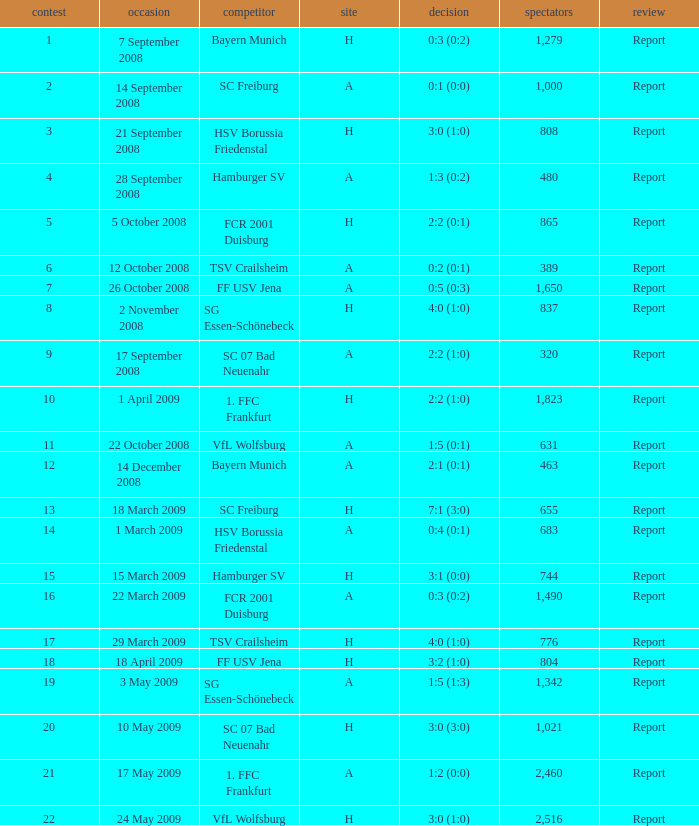What is the match number that had a result of 0:5 (0:3)? 1.0. 